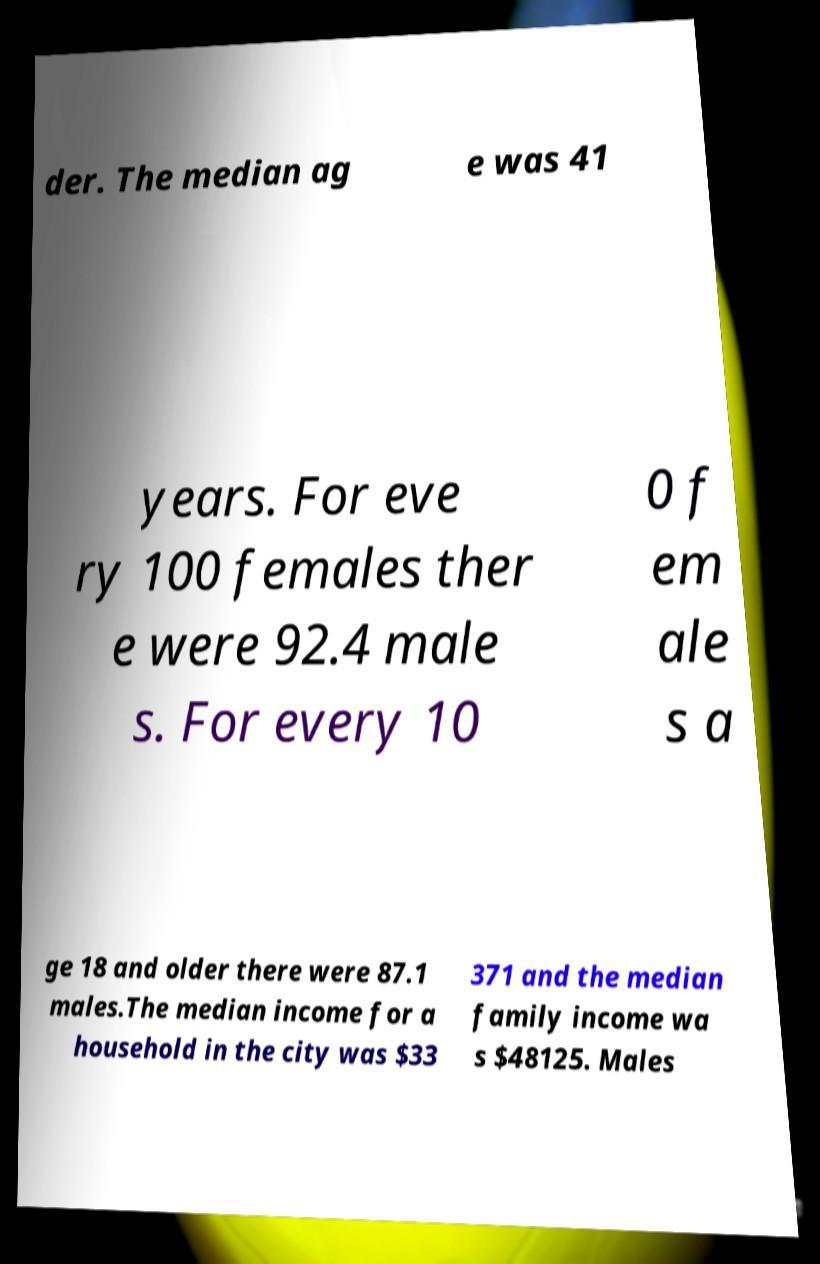For documentation purposes, I need the text within this image transcribed. Could you provide that? der. The median ag e was 41 years. For eve ry 100 females ther e were 92.4 male s. For every 10 0 f em ale s a ge 18 and older there were 87.1 males.The median income for a household in the city was $33 371 and the median family income wa s $48125. Males 